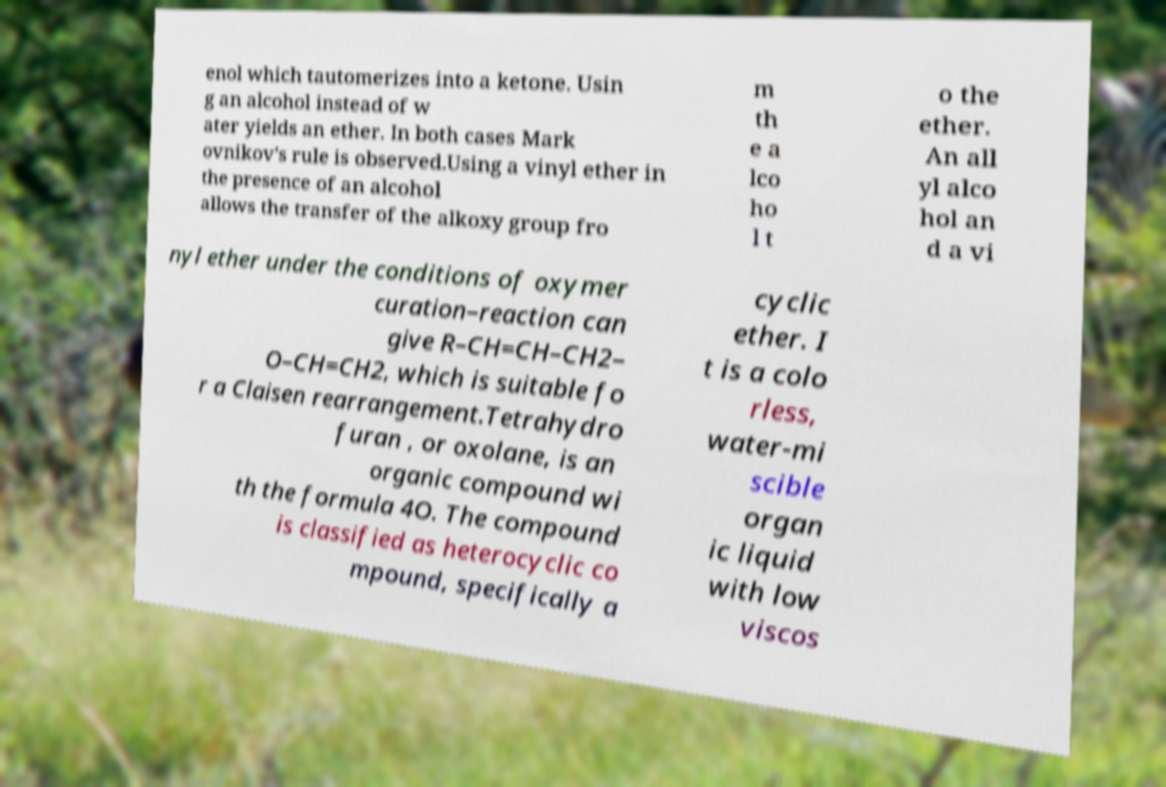For documentation purposes, I need the text within this image transcribed. Could you provide that? enol which tautomerizes into a ketone. Usin g an alcohol instead of w ater yields an ether. In both cases Mark ovnikov's rule is observed.Using a vinyl ether in the presence of an alcohol allows the transfer of the alkoxy group fro m th e a lco ho l t o the ether. An all yl alco hol an d a vi nyl ether under the conditions of oxymer curation–reaction can give R–CH=CH–CH2– O–CH=CH2, which is suitable fo r a Claisen rearrangement.Tetrahydro furan , or oxolane, is an organic compound wi th the formula 4O. The compound is classified as heterocyclic co mpound, specifically a cyclic ether. I t is a colo rless, water-mi scible organ ic liquid with low viscos 